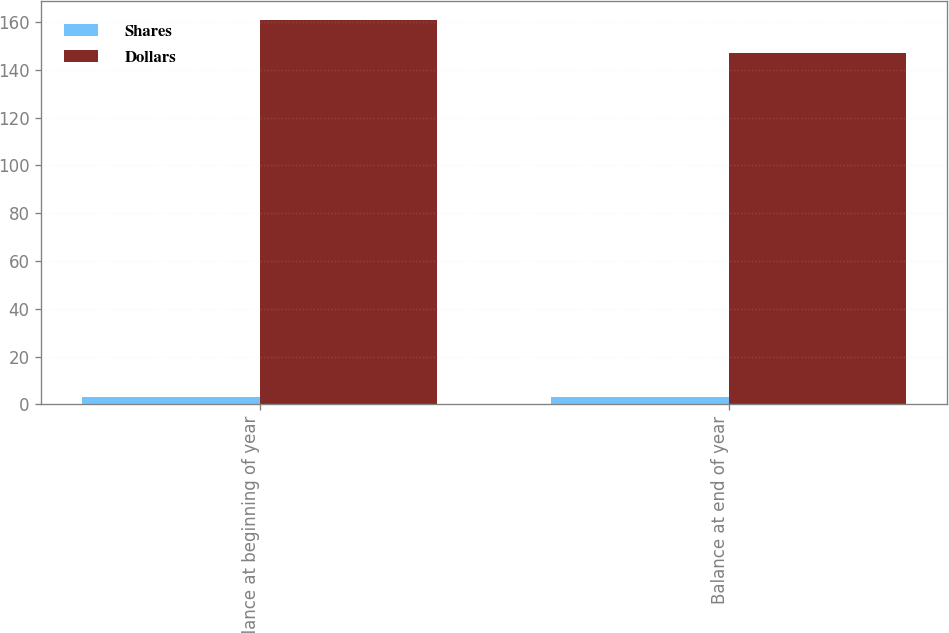Convert chart to OTSL. <chart><loc_0><loc_0><loc_500><loc_500><stacked_bar_chart><ecel><fcel>Balance at beginning of year<fcel>Balance at end of year<nl><fcel>Shares<fcel>3<fcel>3<nl><fcel>Dollars<fcel>161<fcel>147<nl></chart> 